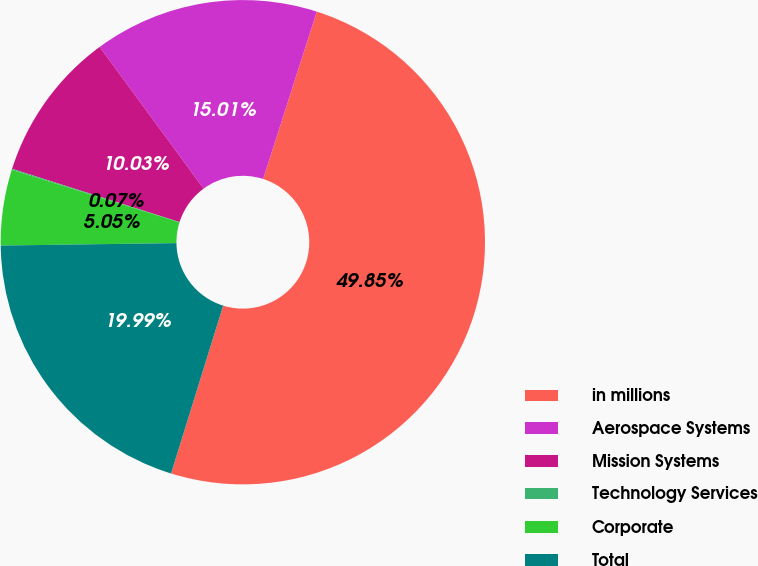<chart> <loc_0><loc_0><loc_500><loc_500><pie_chart><fcel>in millions<fcel>Aerospace Systems<fcel>Mission Systems<fcel>Technology Services<fcel>Corporate<fcel>Total<nl><fcel>49.85%<fcel>15.01%<fcel>10.03%<fcel>0.07%<fcel>5.05%<fcel>19.99%<nl></chart> 